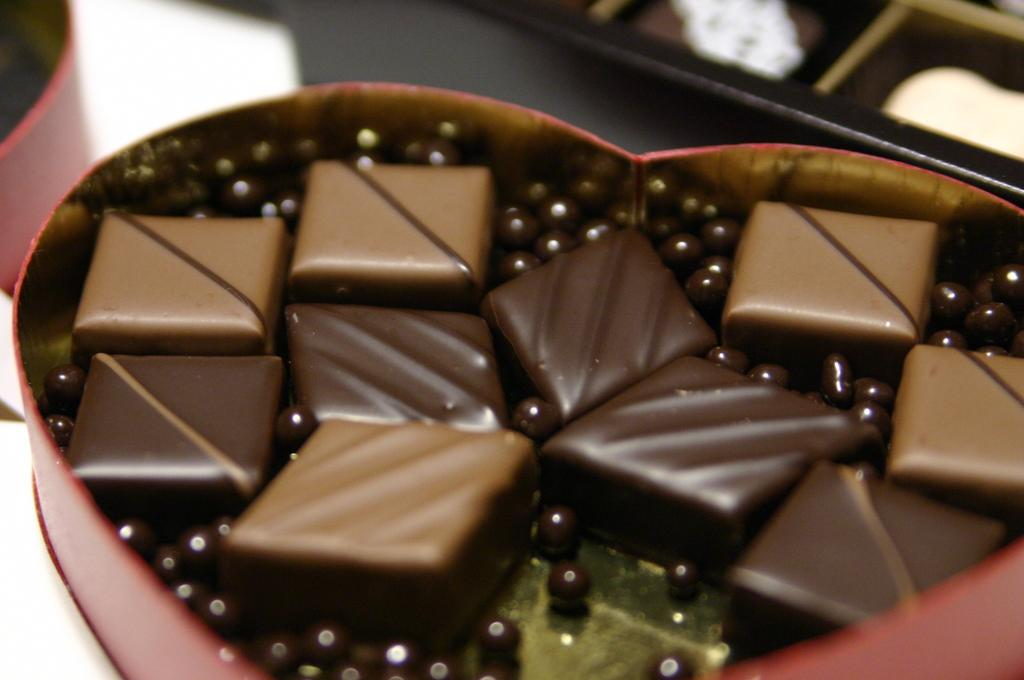What is the main subject of the image? The main subject of the image is a chocolate box. What is inside the chocolate box? The chocolate box contains chocolates. Can you describe anything visible in the background of the image? Unfortunately, the provided facts do not give any information about the objects visible in the background of the image. What type of grape is being used to decorate the chocolate box in the image? There is no grape present in the image, and therefore no such decoration can be observed. Can you tell me how many rakes are leaning against the wall in the background of the image? There is no information provided about the objects visible in the background of the image, so we cannot determine if there are any rakes present. 